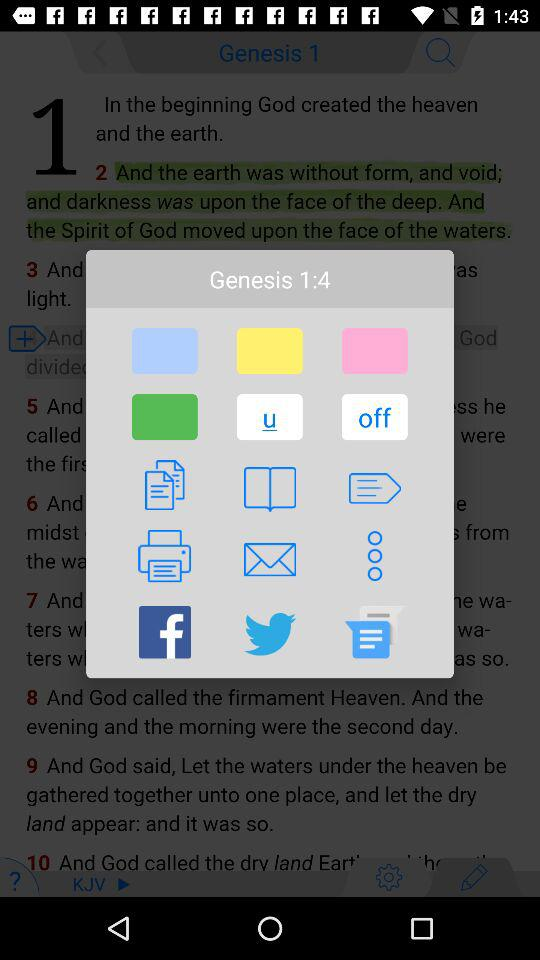What's the current verse of Genesis Book?
When the provided information is insufficient, respond with <no answer>. <no answer> 